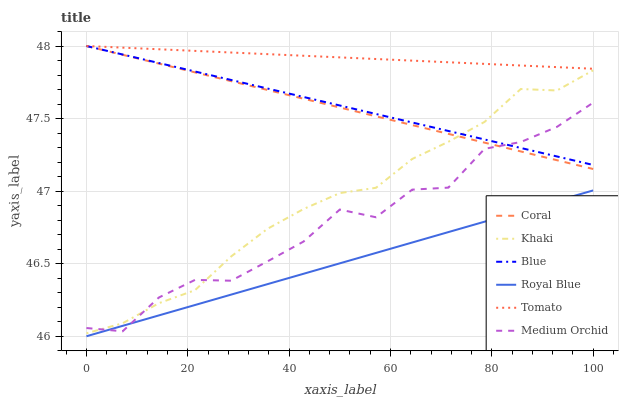Does Royal Blue have the minimum area under the curve?
Answer yes or no. Yes. Does Tomato have the maximum area under the curve?
Answer yes or no. Yes. Does Khaki have the minimum area under the curve?
Answer yes or no. No. Does Khaki have the maximum area under the curve?
Answer yes or no. No. Is Tomato the smoothest?
Answer yes or no. Yes. Is Medium Orchid the roughest?
Answer yes or no. Yes. Is Khaki the smoothest?
Answer yes or no. No. Is Khaki the roughest?
Answer yes or no. No. Does Royal Blue have the lowest value?
Answer yes or no. Yes. Does Khaki have the lowest value?
Answer yes or no. No. Does Coral have the highest value?
Answer yes or no. Yes. Does Khaki have the highest value?
Answer yes or no. No. Is Khaki less than Tomato?
Answer yes or no. Yes. Is Blue greater than Royal Blue?
Answer yes or no. Yes. Does Blue intersect Medium Orchid?
Answer yes or no. Yes. Is Blue less than Medium Orchid?
Answer yes or no. No. Is Blue greater than Medium Orchid?
Answer yes or no. No. Does Khaki intersect Tomato?
Answer yes or no. No. 